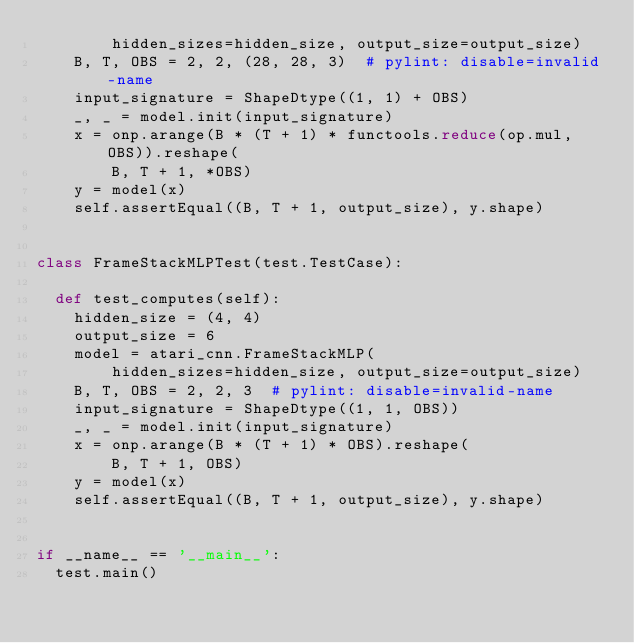Convert code to text. <code><loc_0><loc_0><loc_500><loc_500><_Python_>        hidden_sizes=hidden_size, output_size=output_size)
    B, T, OBS = 2, 2, (28, 28, 3)  # pylint: disable=invalid-name
    input_signature = ShapeDtype((1, 1) + OBS)
    _, _ = model.init(input_signature)
    x = onp.arange(B * (T + 1) * functools.reduce(op.mul, OBS)).reshape(
        B, T + 1, *OBS)
    y = model(x)
    self.assertEqual((B, T + 1, output_size), y.shape)


class FrameStackMLPTest(test.TestCase):

  def test_computes(self):
    hidden_size = (4, 4)
    output_size = 6
    model = atari_cnn.FrameStackMLP(
        hidden_sizes=hidden_size, output_size=output_size)
    B, T, OBS = 2, 2, 3  # pylint: disable=invalid-name
    input_signature = ShapeDtype((1, 1, OBS))
    _, _ = model.init(input_signature)
    x = onp.arange(B * (T + 1) * OBS).reshape(
        B, T + 1, OBS)
    y = model(x)
    self.assertEqual((B, T + 1, output_size), y.shape)


if __name__ == '__main__':
  test.main()
</code> 